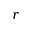Convert formula to latex. <formula><loc_0><loc_0><loc_500><loc_500>r</formula> 